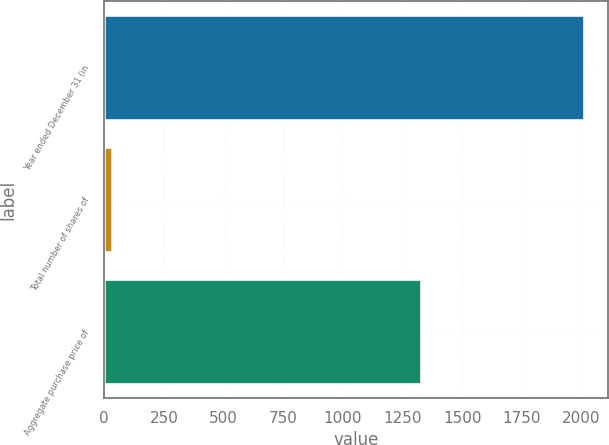Convert chart. <chart><loc_0><loc_0><loc_500><loc_500><bar_chart><fcel>Year ended December 31 (in<fcel>Total number of shares of<fcel>Aggregate purchase price of<nl><fcel>2012<fcel>30.9<fcel>1329<nl></chart> 